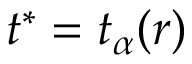<formula> <loc_0><loc_0><loc_500><loc_500>t ^ { * } = t _ { \alpha } ( r )</formula> 